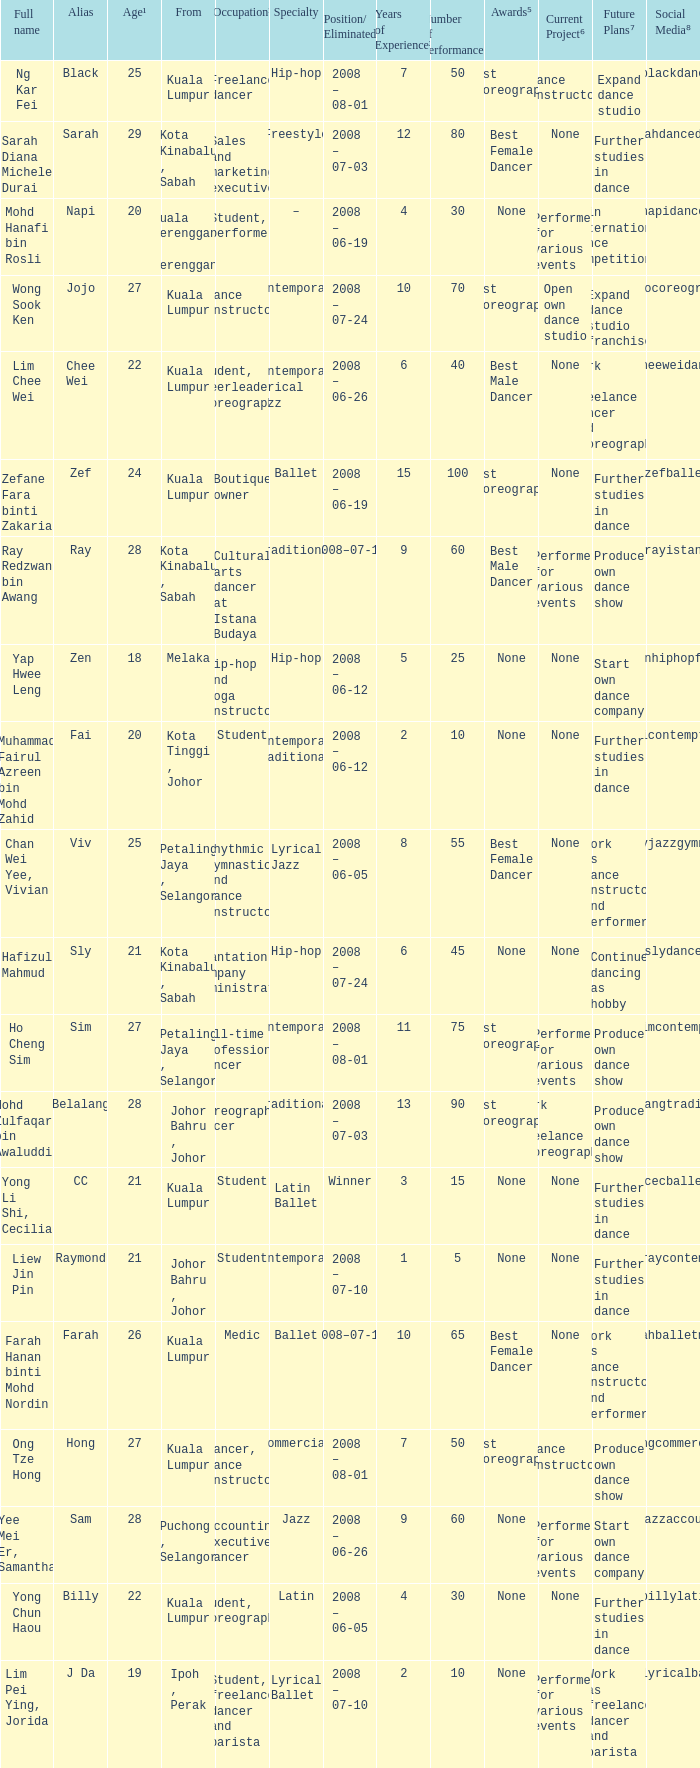What is Occupation², when Age¹ is greater than 24, when Alias is "Black"? Freelance dancer. 